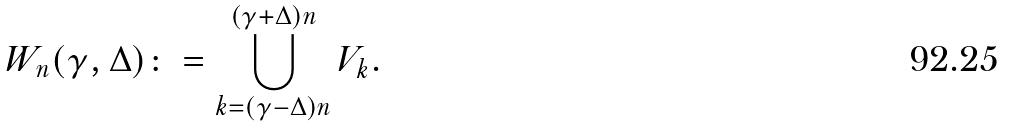<formula> <loc_0><loc_0><loc_500><loc_500>W _ { n } ( \gamma , \Delta ) \colon = \bigcup _ { k = ( \gamma - \Delta ) n } ^ { ( \gamma + \Delta ) n } V _ { k } .</formula> 